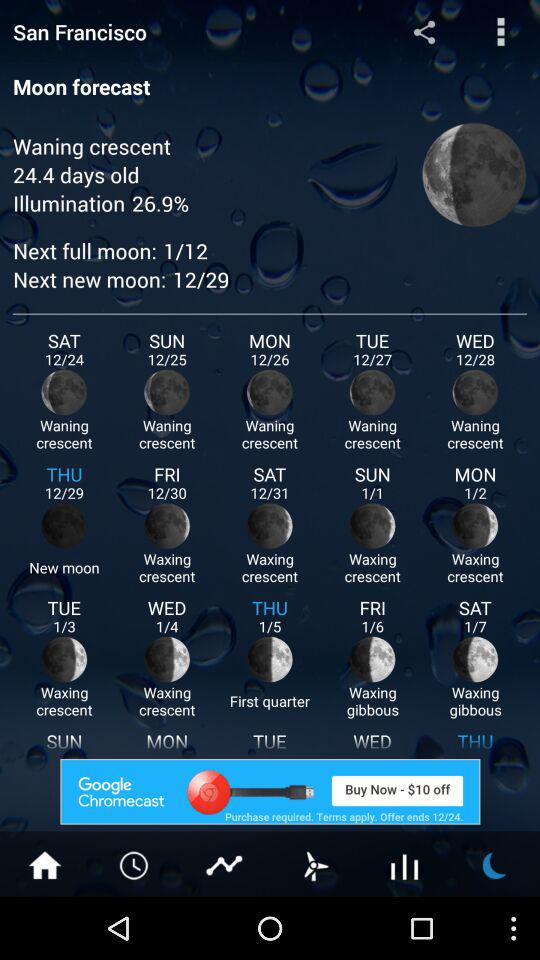What is the waning crescent?
When the provided information is insufficient, respond with <no answer>. <no answer> 